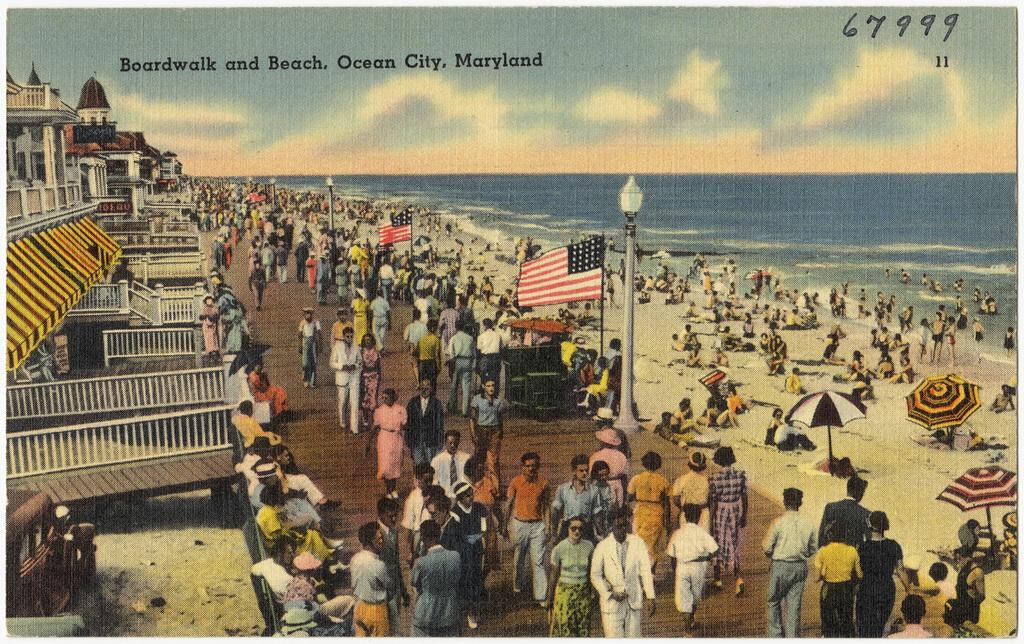<image>
Relay a brief, clear account of the picture shown. a poster picture that says 'boardwalk and beach, ocean city, maryland' 